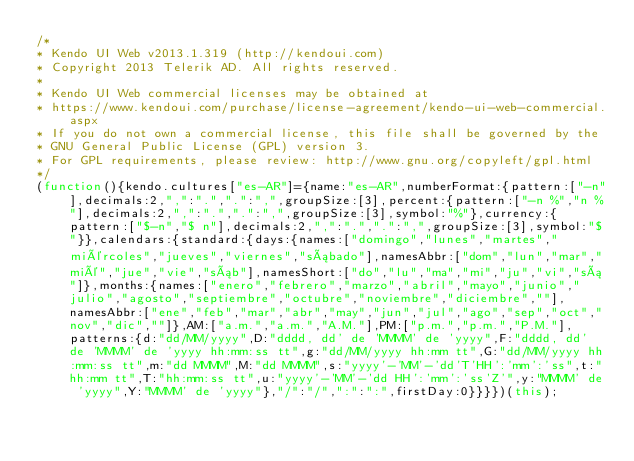<code> <loc_0><loc_0><loc_500><loc_500><_JavaScript_>/*
* Kendo UI Web v2013.1.319 (http://kendoui.com)
* Copyright 2013 Telerik AD. All rights reserved.
*
* Kendo UI Web commercial licenses may be obtained at
* https://www.kendoui.com/purchase/license-agreement/kendo-ui-web-commercial.aspx
* If you do not own a commercial license, this file shall be governed by the
* GNU General Public License (GPL) version 3.
* For GPL requirements, please review: http://www.gnu.org/copyleft/gpl.html
*/
(function(){kendo.cultures["es-AR"]={name:"es-AR",numberFormat:{pattern:["-n"],decimals:2,",":".",".":",",groupSize:[3],percent:{pattern:["-n %","n %"],decimals:2,",":".",".":",",groupSize:[3],symbol:"%"},currency:{pattern:["$-n","$ n"],decimals:2,",":".",".":",",groupSize:[3],symbol:"$"}},calendars:{standard:{days:{names:["domingo","lunes","martes","miércoles","jueves","viernes","sábado"],namesAbbr:["dom","lun","mar","mié","jue","vie","sáb"],namesShort:["do","lu","ma","mi","ju","vi","sá"]},months:{names:["enero","febrero","marzo","abril","mayo","junio","julio","agosto","septiembre","octubre","noviembre","diciembre",""],namesAbbr:["ene","feb","mar","abr","may","jun","jul","ago","sep","oct","nov","dic",""]},AM:["a.m.","a.m.","A.M."],PM:["p.m.","p.m.","P.M."],patterns:{d:"dd/MM/yyyy",D:"dddd, dd' de 'MMMM' de 'yyyy",F:"dddd, dd' de 'MMMM' de 'yyyy hh:mm:ss tt",g:"dd/MM/yyyy hh:mm tt",G:"dd/MM/yyyy hh:mm:ss tt",m:"dd MMMM",M:"dd MMMM",s:"yyyy'-'MM'-'dd'T'HH':'mm':'ss",t:"hh:mm tt",T:"hh:mm:ss tt",u:"yyyy'-'MM'-'dd HH':'mm':'ss'Z'",y:"MMMM' de 'yyyy",Y:"MMMM' de 'yyyy"},"/":"/",":":":",firstDay:0}}}})(this);</code> 